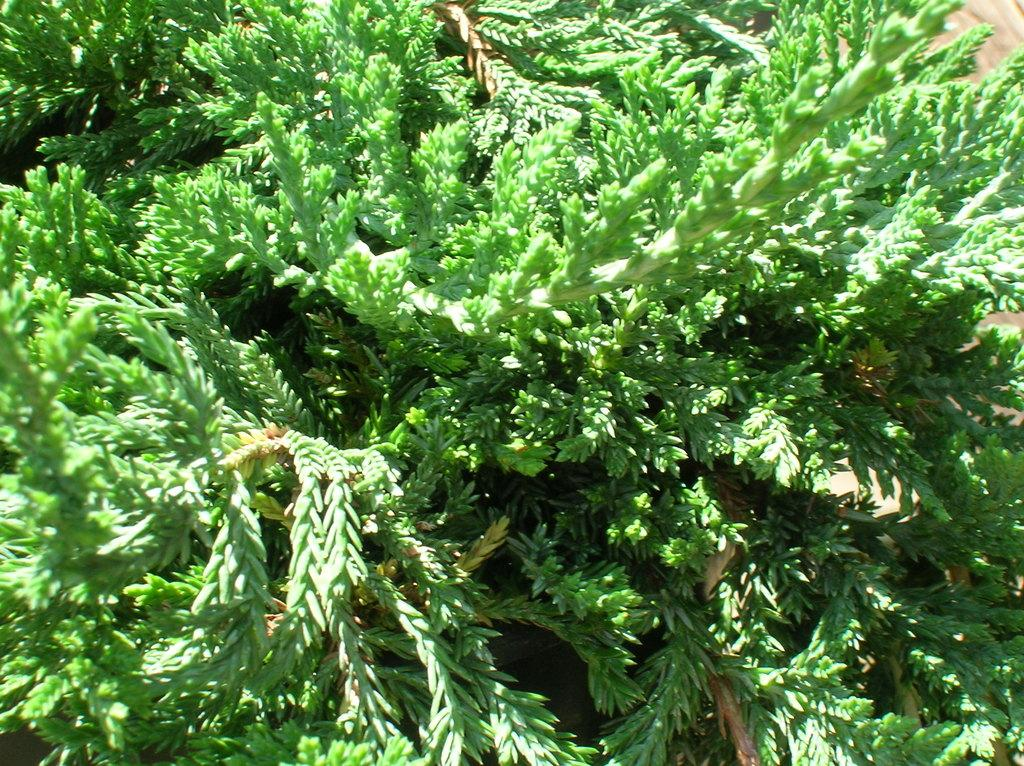What type of vegetation is present in the image? There are leaves in the image. How many fingers can be seen playing the prose in the image? There are no fingers or prose present in the image; it only features leaves. 